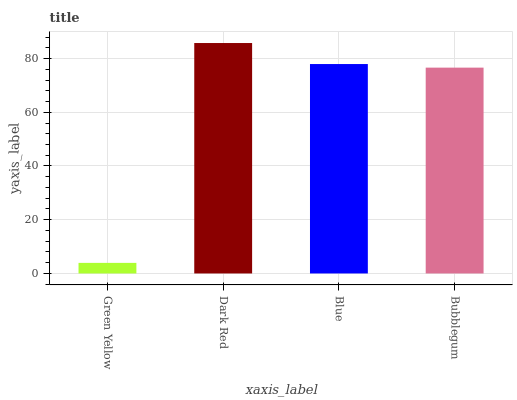Is Green Yellow the minimum?
Answer yes or no. Yes. Is Dark Red the maximum?
Answer yes or no. Yes. Is Blue the minimum?
Answer yes or no. No. Is Blue the maximum?
Answer yes or no. No. Is Dark Red greater than Blue?
Answer yes or no. Yes. Is Blue less than Dark Red?
Answer yes or no. Yes. Is Blue greater than Dark Red?
Answer yes or no. No. Is Dark Red less than Blue?
Answer yes or no. No. Is Blue the high median?
Answer yes or no. Yes. Is Bubblegum the low median?
Answer yes or no. Yes. Is Bubblegum the high median?
Answer yes or no. No. Is Dark Red the low median?
Answer yes or no. No. 